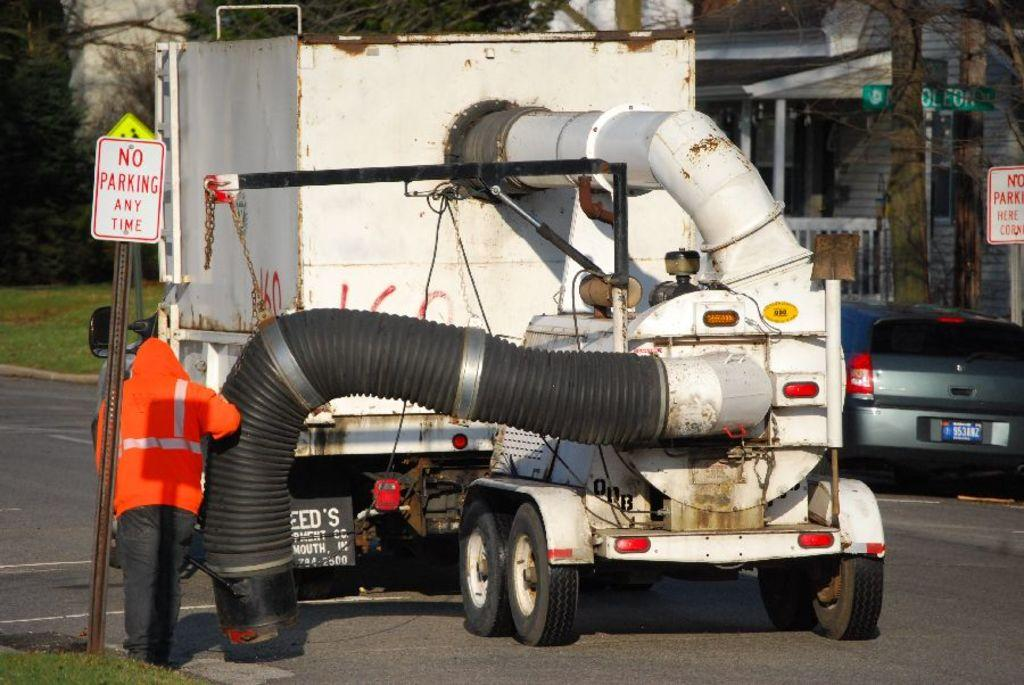What is the main subject of the image? There is a person in the image. What can be seen in the background of the image? Trees are present in the background of the image. What type of structures are visible in the image? There is a building in the image. What is located on the road in the image? There are vehicles on the road in the image. What type of vegetation is visible in the image? Grass is visible in the image. Are there any signs or markers in the image? Name boards are present in the image. What else can be seen in the image besides the person, vehicles, building, and trees? There are some objects in the image. What type of amusement can be seen on the earth in the image? There is no amusement or earth mentioned in the image; it features a person, vehicles, a building, trees, grass, and name boards. 